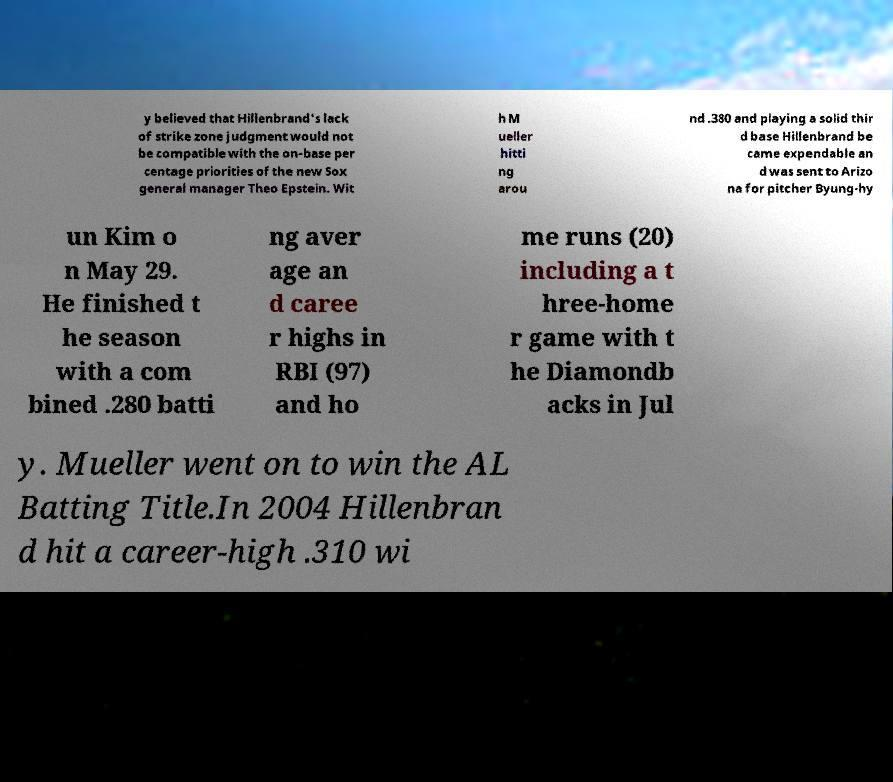Could you extract and type out the text from this image? y believed that Hillenbrand's lack of strike zone judgment would not be compatible with the on-base per centage priorities of the new Sox general manager Theo Epstein. Wit h M ueller hitti ng arou nd .380 and playing a solid thir d base Hillenbrand be came expendable an d was sent to Arizo na for pitcher Byung-hy un Kim o n May 29. He finished t he season with a com bined .280 batti ng aver age an d caree r highs in RBI (97) and ho me runs (20) including a t hree-home r game with t he Diamondb acks in Jul y. Mueller went on to win the AL Batting Title.In 2004 Hillenbran d hit a career-high .310 wi 